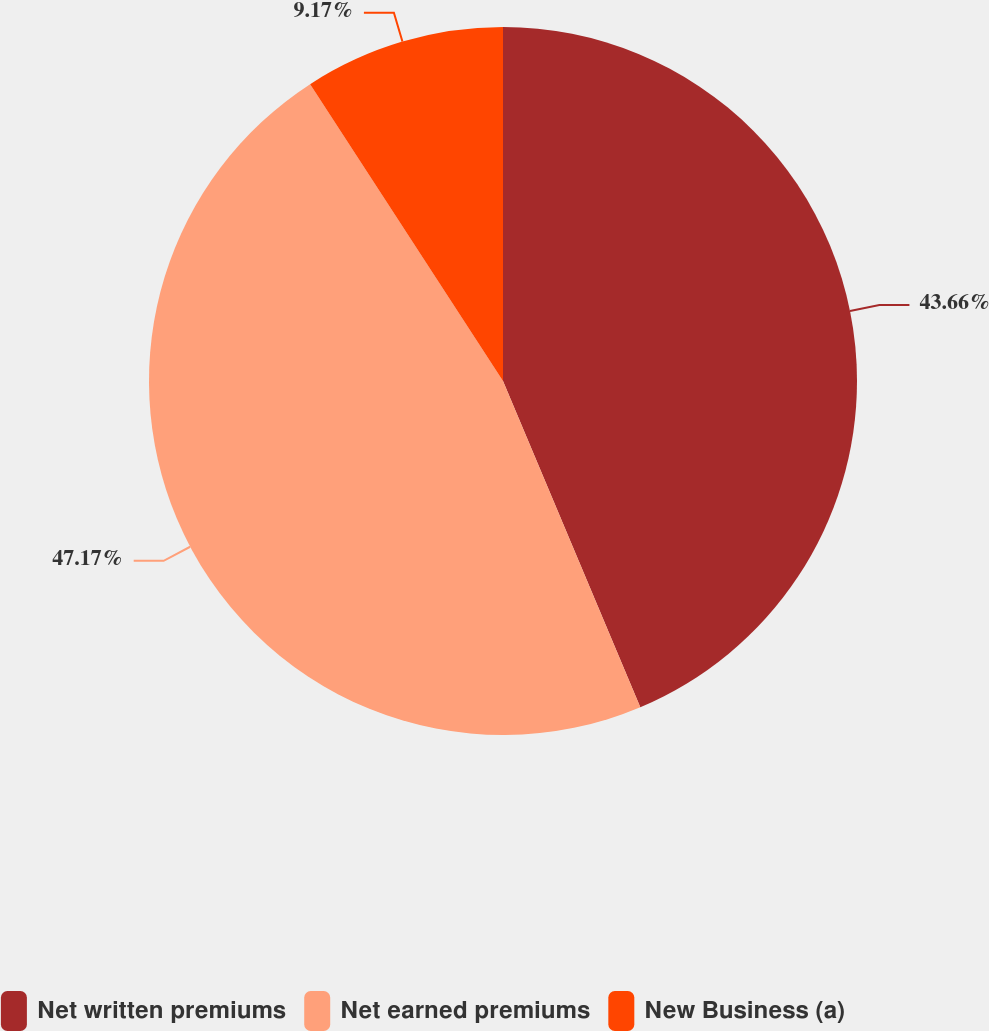<chart> <loc_0><loc_0><loc_500><loc_500><pie_chart><fcel>Net written premiums<fcel>Net earned premiums<fcel>New Business (a)<nl><fcel>43.66%<fcel>47.17%<fcel>9.17%<nl></chart> 